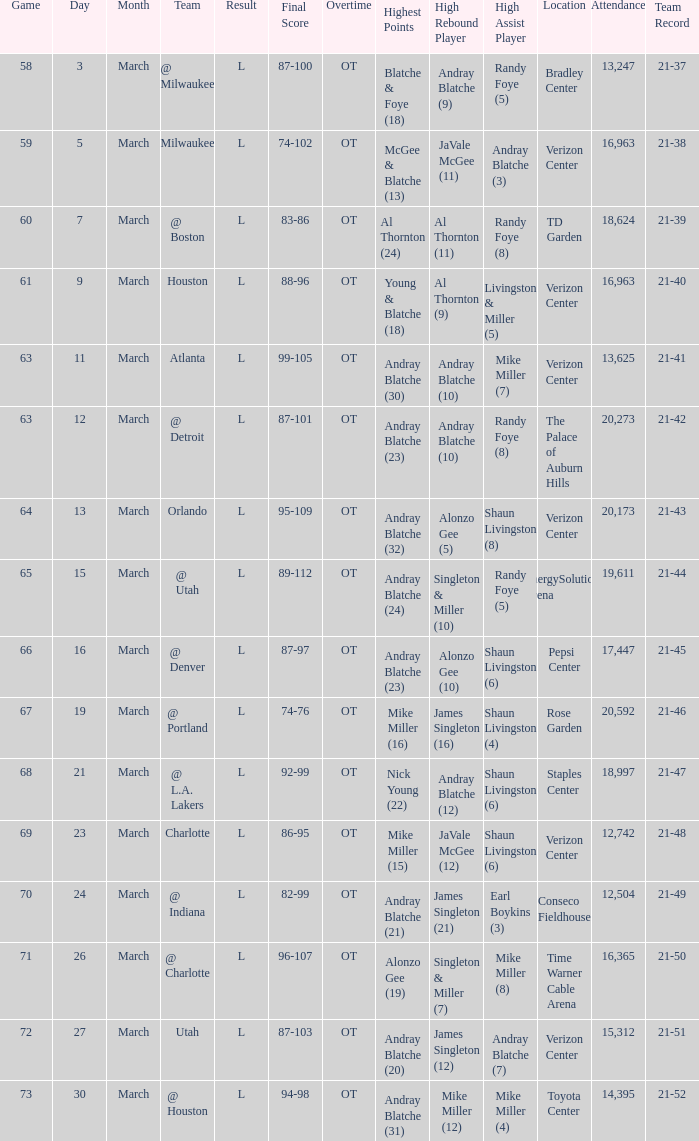On what date was the attendance at TD Garden 18,624? March 7. 